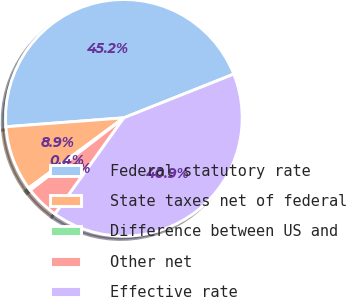Convert chart to OTSL. <chart><loc_0><loc_0><loc_500><loc_500><pie_chart><fcel>Federal statutory rate<fcel>State taxes net of federal<fcel>Difference between US and<fcel>Other net<fcel>Effective rate<nl><fcel>45.18%<fcel>8.9%<fcel>0.37%<fcel>4.63%<fcel>40.92%<nl></chart> 